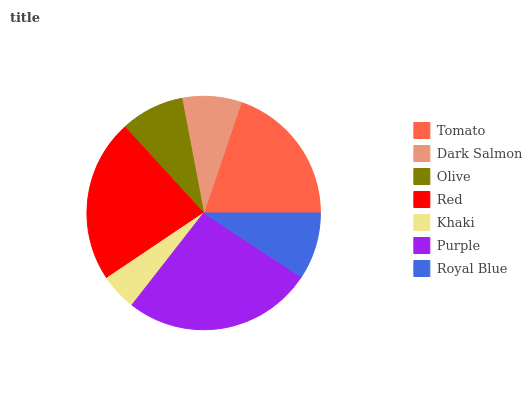Is Khaki the minimum?
Answer yes or no. Yes. Is Purple the maximum?
Answer yes or no. Yes. Is Dark Salmon the minimum?
Answer yes or no. No. Is Dark Salmon the maximum?
Answer yes or no. No. Is Tomato greater than Dark Salmon?
Answer yes or no. Yes. Is Dark Salmon less than Tomato?
Answer yes or no. Yes. Is Dark Salmon greater than Tomato?
Answer yes or no. No. Is Tomato less than Dark Salmon?
Answer yes or no. No. Is Royal Blue the high median?
Answer yes or no. Yes. Is Royal Blue the low median?
Answer yes or no. Yes. Is Purple the high median?
Answer yes or no. No. Is Red the low median?
Answer yes or no. No. 